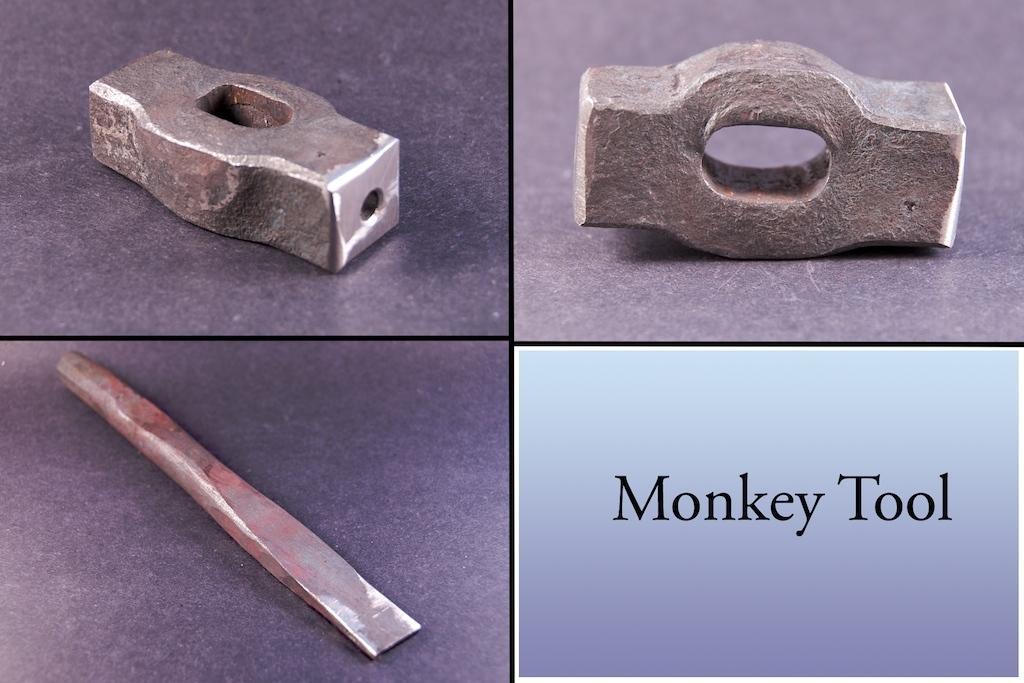Describe this image in one or two sentences. In this picture I can see the collage image. I can see three metal objects and text. 